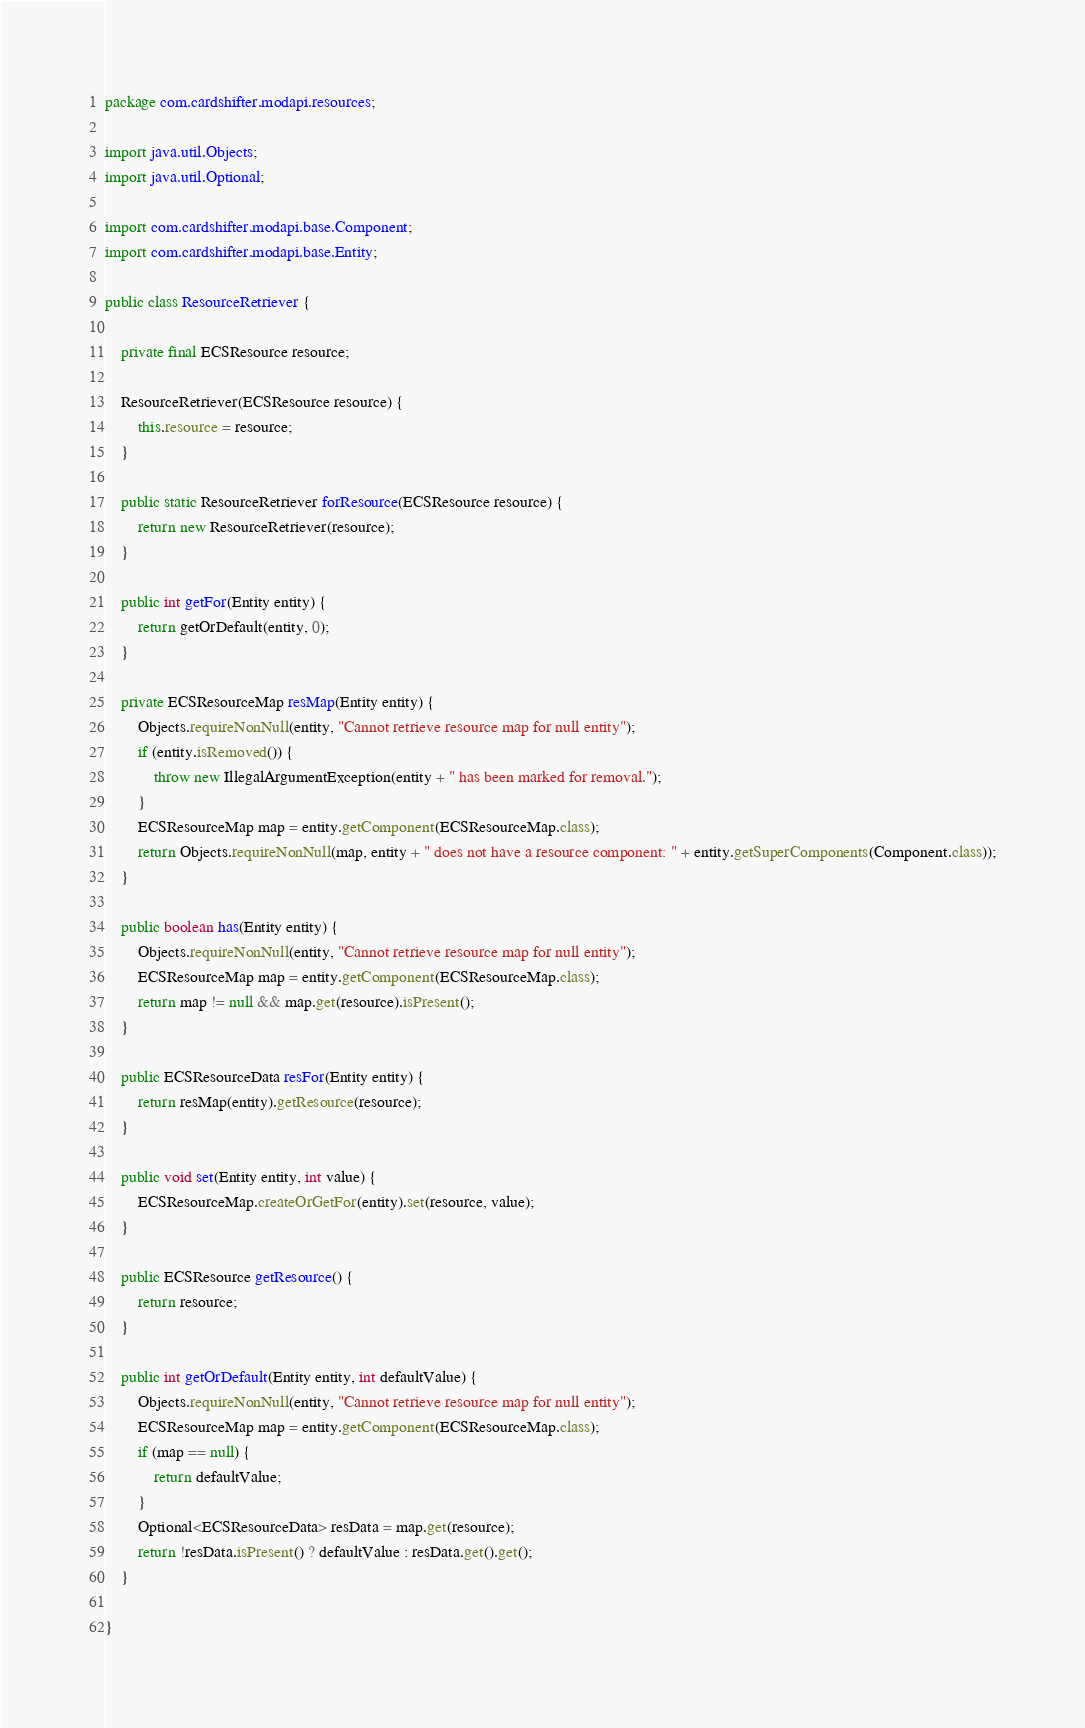Convert code to text. <code><loc_0><loc_0><loc_500><loc_500><_Java_>package com.cardshifter.modapi.resources;

import java.util.Objects;
import java.util.Optional;

import com.cardshifter.modapi.base.Component;
import com.cardshifter.modapi.base.Entity;

public class ResourceRetriever {

	private final ECSResource resource;

	ResourceRetriever(ECSResource resource) {
		this.resource = resource;
	}
	
	public static ResourceRetriever forResource(ECSResource resource) {
		return new ResourceRetriever(resource);
	}

	public int getFor(Entity entity) {
        return getOrDefault(entity, 0);
	}

	private ECSResourceMap resMap(Entity entity) {
		Objects.requireNonNull(entity, "Cannot retrieve resource map for null entity");
		if (entity.isRemoved()) {
			throw new IllegalArgumentException(entity + " has been marked for removal.");
		}
		ECSResourceMap map = entity.getComponent(ECSResourceMap.class);
		return Objects.requireNonNull(map, entity + " does not have a resource component: " + entity.getSuperComponents(Component.class));
	}
	
	public boolean has(Entity entity) {
		Objects.requireNonNull(entity, "Cannot retrieve resource map for null entity");
		ECSResourceMap map = entity.getComponent(ECSResourceMap.class);
		return map != null && map.get(resource).isPresent();
	}

	public ECSResourceData resFor(Entity entity) {
		return resMap(entity).getResource(resource);
	}

	public void set(Entity entity, int value) {
		ECSResourceMap.createOrGetFor(entity).set(resource, value);
	}

	public ECSResource getResource() {
		return resource;
	}

	public int getOrDefault(Entity entity, int defaultValue) {
		Objects.requireNonNull(entity, "Cannot retrieve resource map for null entity");
		ECSResourceMap map = entity.getComponent(ECSResourceMap.class);
		if (map == null) {
			return defaultValue;
		}
		Optional<ECSResourceData> resData = map.get(resource);
		return !resData.isPresent() ? defaultValue : resData.get().get();
	}
	
}
</code> 